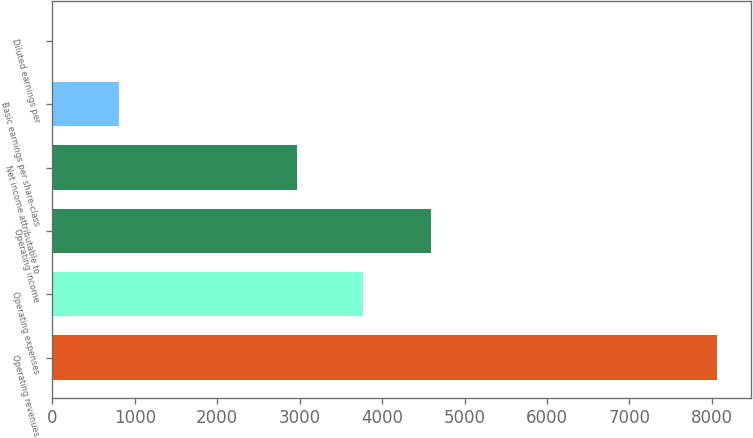Convert chart. <chart><loc_0><loc_0><loc_500><loc_500><bar_chart><fcel>Operating revenues<fcel>Operating expenses<fcel>Operating income<fcel>Net income attributable to<fcel>Basic earnings per share-class<fcel>Diluted earnings per<nl><fcel>8065<fcel>3772.1<fcel>4589<fcel>2966<fcel>810.11<fcel>4.01<nl></chart> 